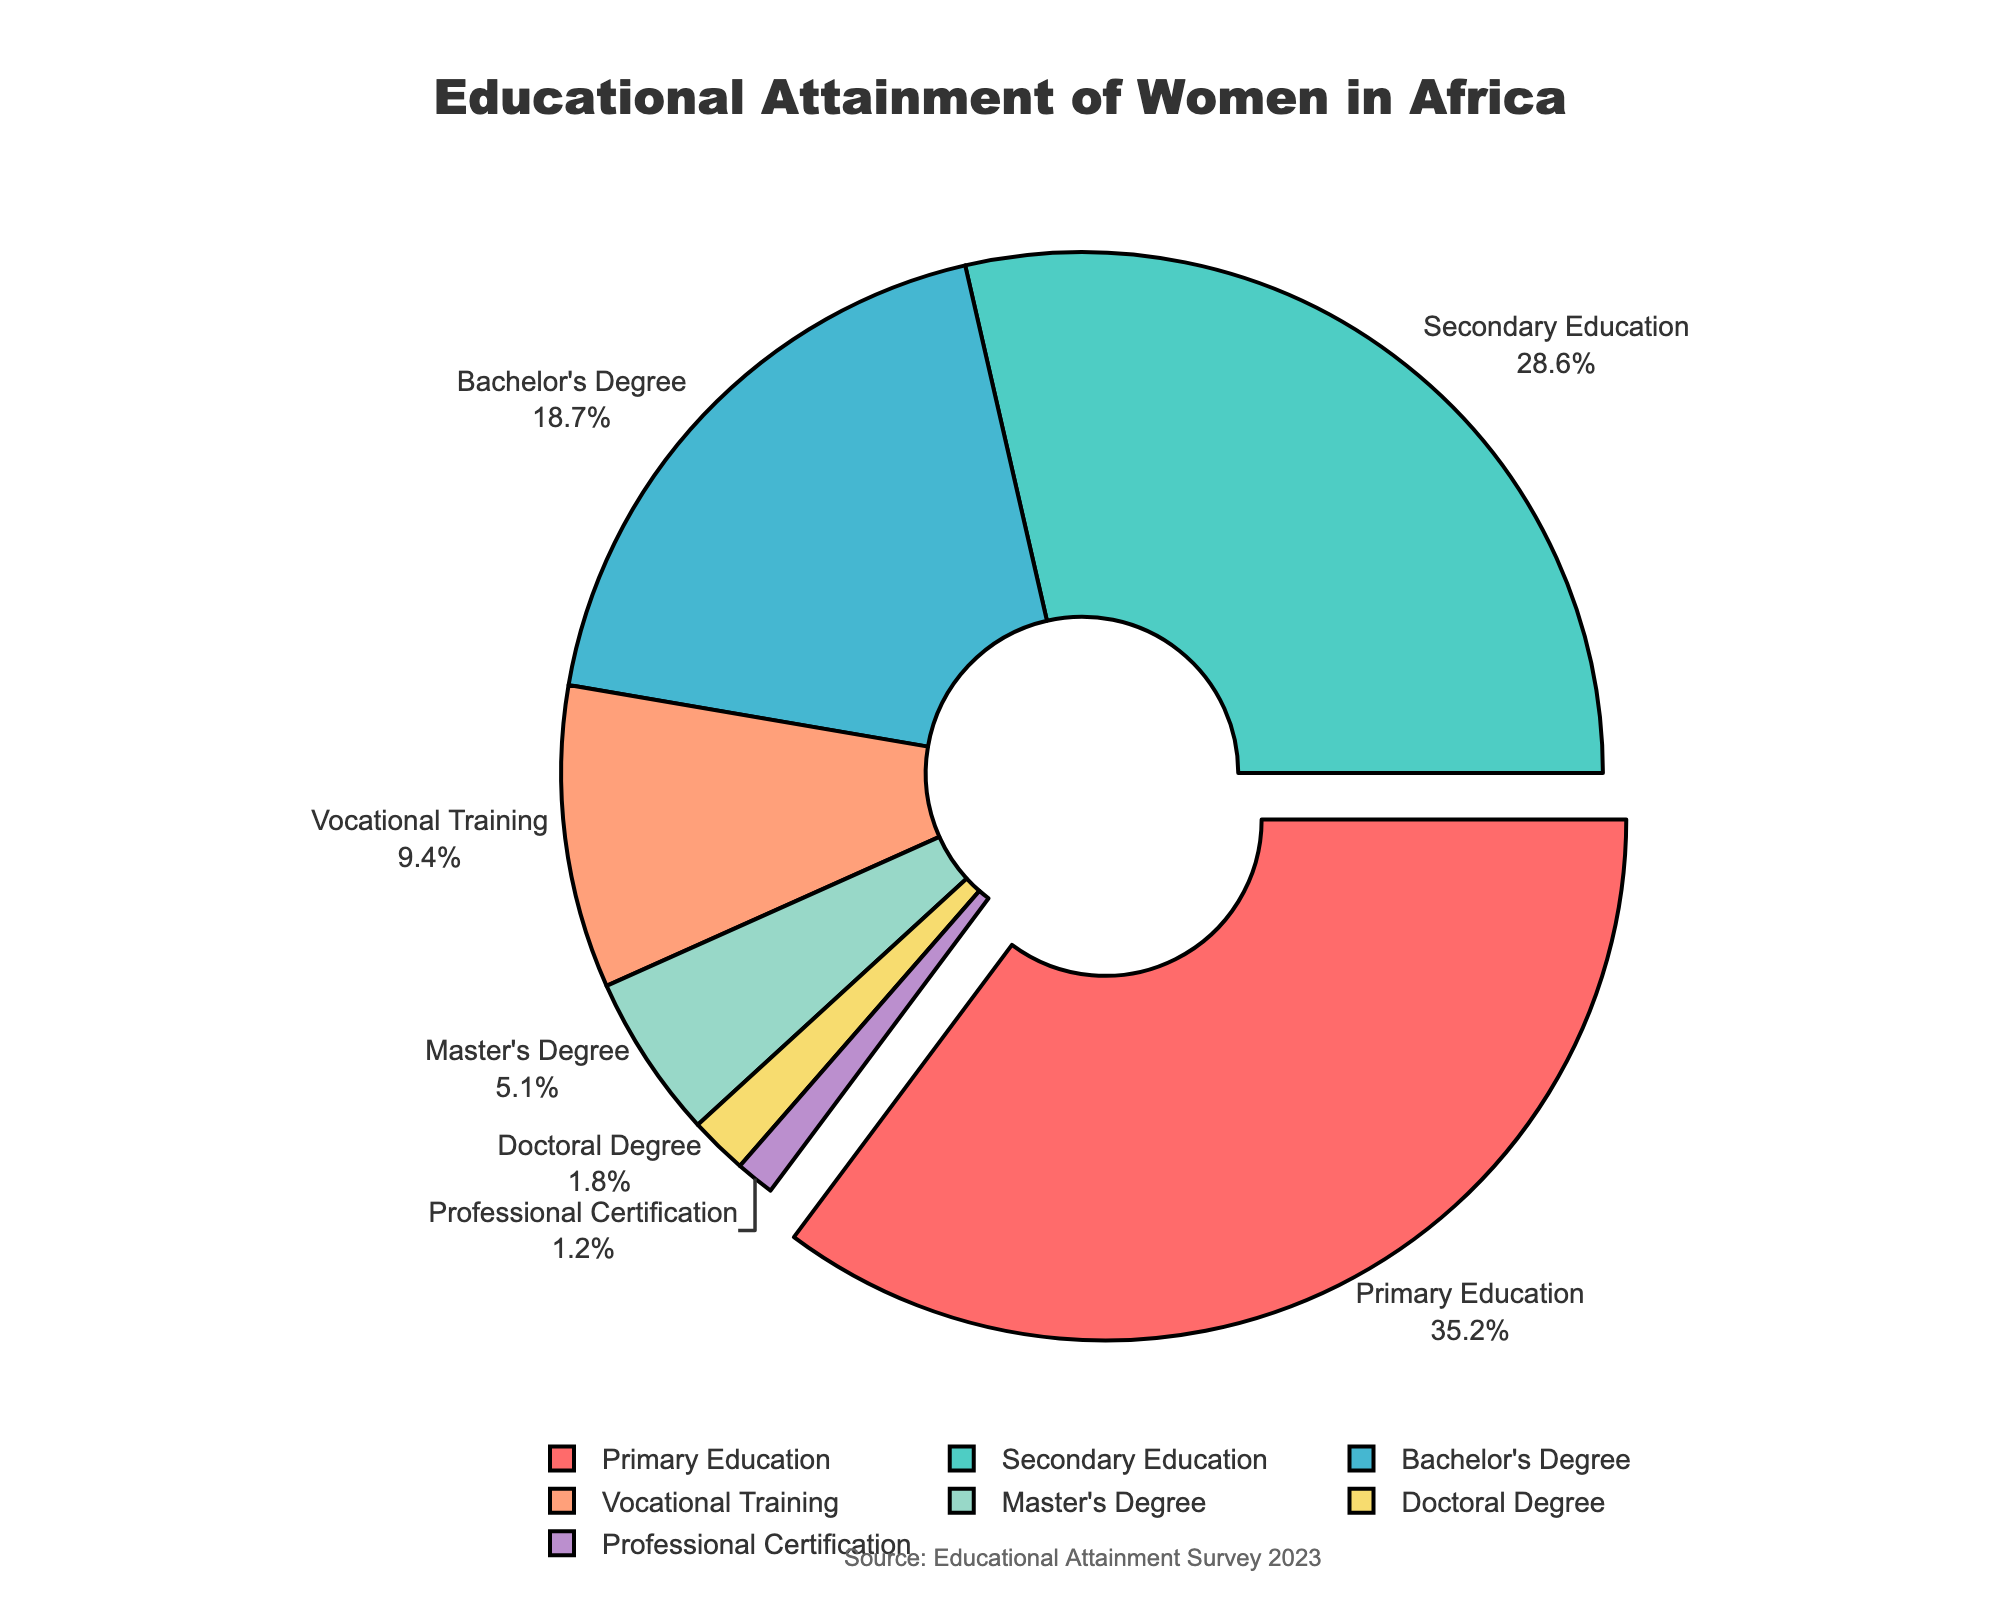What's the percentage of women who have achieved a Bachelor's Degree or higher? To find the percentage of women who have achieved a Bachelor's Degree or higher, we need to sum the percentages of those with a Bachelor's Degree, Master's Degree, Doctoral Degree, and Professional Certification. This is calculated as 18.7 + 5.1 + 1.8 + 1.2 = 26.8%.
Answer: 26.8% Which degree type has the highest attainment percentage? According to the pie chart, the degree type with the highest attainment percentage is Primary Education, at 35.2%.
Answer: Primary Education What is the difference in percentage between Secondary Education and Vocational Training? To find the difference in percentage between Secondary Education and Vocational Training, we subtract the percentage of Vocational Training from the percentage of Secondary Education: 28.6 - 9.4 = 19.2%.
Answer: 19.2% What is the total percentage of women with a Master's Degree or a Doctoral Degree? To find the total percentage of women with a Master's or Doctoral Degree, sum the percentages of both degree types: 5.1 + 1.8 = 6.9%.
Answer: 6.9% Which degree type shows up the smallest percentage slice in the pie chart? According to the pie chart, the degree type with the smallest percentage slice is Professional Certification, at 1.2%.
Answer: Professional Certification What is the average percentage of women who attained Bachelor's, Master's, and Doctoral Degrees? To calculate the average, sum the percentages for Bachelor's, Master's, and Doctoral Degrees and then divide by 3: (18.7 + 5.1 + 1.8) / 3 = 8.533%.
Answer: 8.533% How much larger is the slice for Secondary Education compared to the slice for Master's Degree? To determine how much larger the slice for Secondary Education is compared to the slice for Master's Degree, subtract the percentage for the Master's Degree from the percentage for Secondary Education: 28.6 - 5.1 = 23.5%.
Answer: 23.5% If the pie chart rotated by 90 degrees clockwise, which degree type would be at the top? Given the current configuration where the primary slice is pulled out and labeled, if the chart is rotated by 90 degrees clockwise, the slice for Primary Education (currently at 90 degrees) would be at the top.
Answer: Primary Education What is the combined percentage of women attaining Secondary and Primary Education? To find this combined percentage, sum the percentages for Secondary and Primary Education: 28.6 + 35.2 = 63.8%.
Answer: 63.8% Compare the percentages of women achieving Vocational Training and Doctoral Degree and state which one is higher. By examining the pie chart, we notice that the percentage for Vocational Training is 9.4%, which is higher than the percentage for Doctoral Degree at 1.8%.
Answer: Vocational Training 